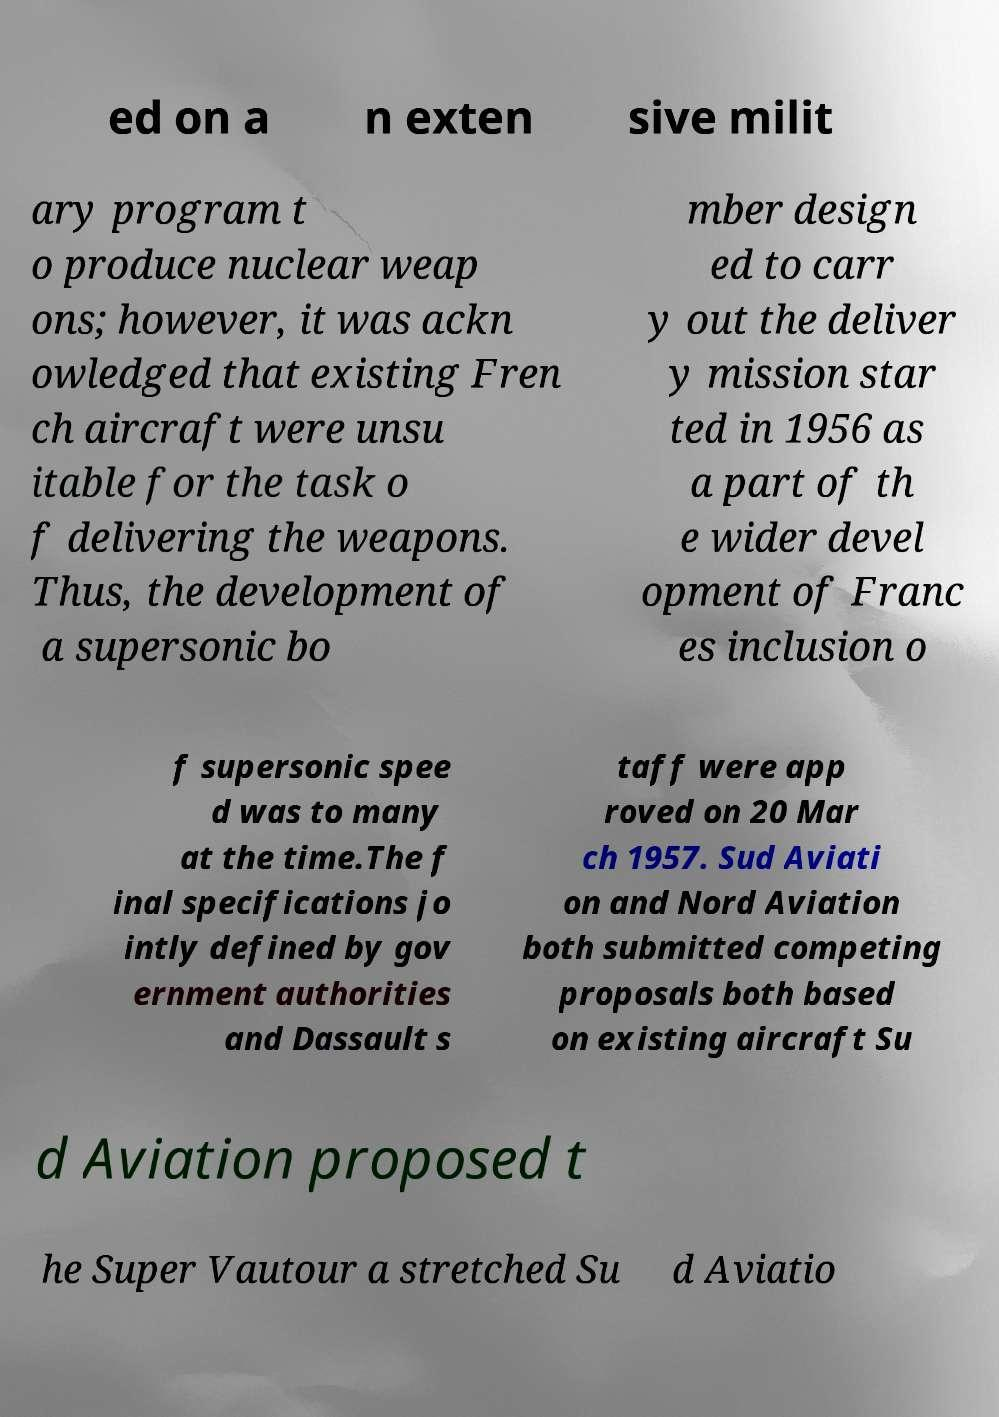Can you accurately transcribe the text from the provided image for me? ed on a n exten sive milit ary program t o produce nuclear weap ons; however, it was ackn owledged that existing Fren ch aircraft were unsu itable for the task o f delivering the weapons. Thus, the development of a supersonic bo mber design ed to carr y out the deliver y mission star ted in 1956 as a part of th e wider devel opment of Franc es inclusion o f supersonic spee d was to many at the time.The f inal specifications jo intly defined by gov ernment authorities and Dassault s taff were app roved on 20 Mar ch 1957. Sud Aviati on and Nord Aviation both submitted competing proposals both based on existing aircraft Su d Aviation proposed t he Super Vautour a stretched Su d Aviatio 